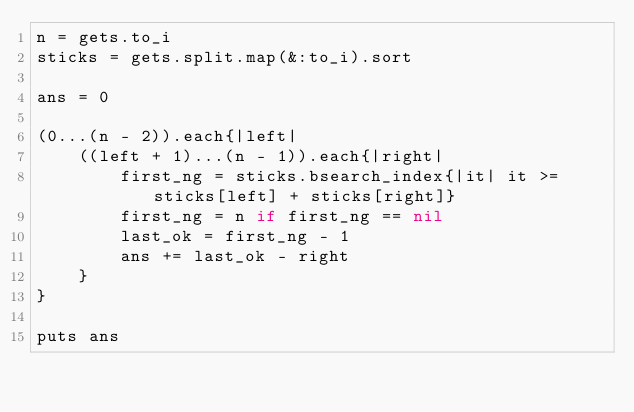<code> <loc_0><loc_0><loc_500><loc_500><_Ruby_>n = gets.to_i
sticks = gets.split.map(&:to_i).sort

ans = 0

(0...(n - 2)).each{|left|
    ((left + 1)...(n - 1)).each{|right|
        first_ng = sticks.bsearch_index{|it| it >= sticks[left] + sticks[right]}
        first_ng = n if first_ng == nil 
        last_ok = first_ng - 1
        ans += last_ok - right
    }
}

puts ans</code> 